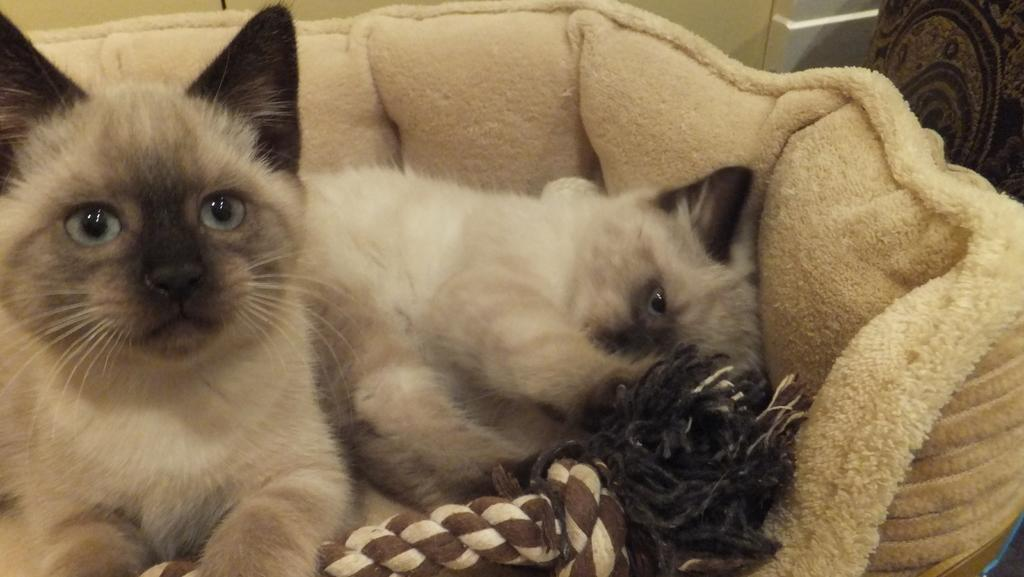What animals are present in the image? There are cats in the image. Where are the cats located? The cats are on a couch. What can be seen in the background of the image? There is a wall visible in the background of the image. What is the view like outside during the rainstorm in the image? There is no rainstorm present in the image, and therefore no view to describe. 